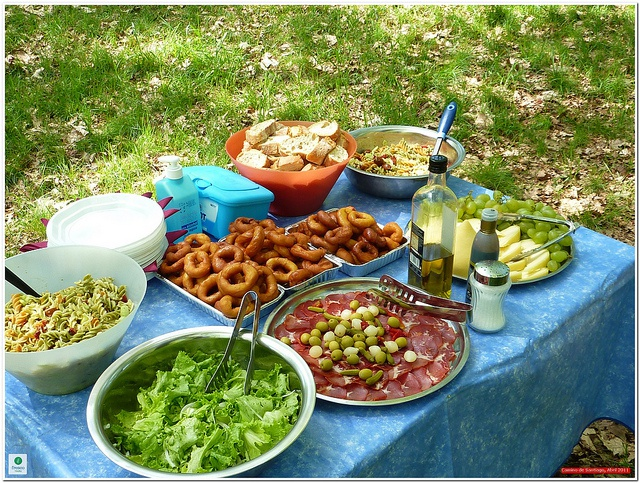Describe the objects in this image and their specific colors. I can see dining table in white, lightblue, gray, and blue tones, bowl in white, lightgray, beige, khaki, and darkgreen tones, donut in white, maroon, brown, black, and orange tones, bowl in white, ivory, and darkgreen tones, and bowl in white, beige, orange, maroon, and khaki tones in this image. 